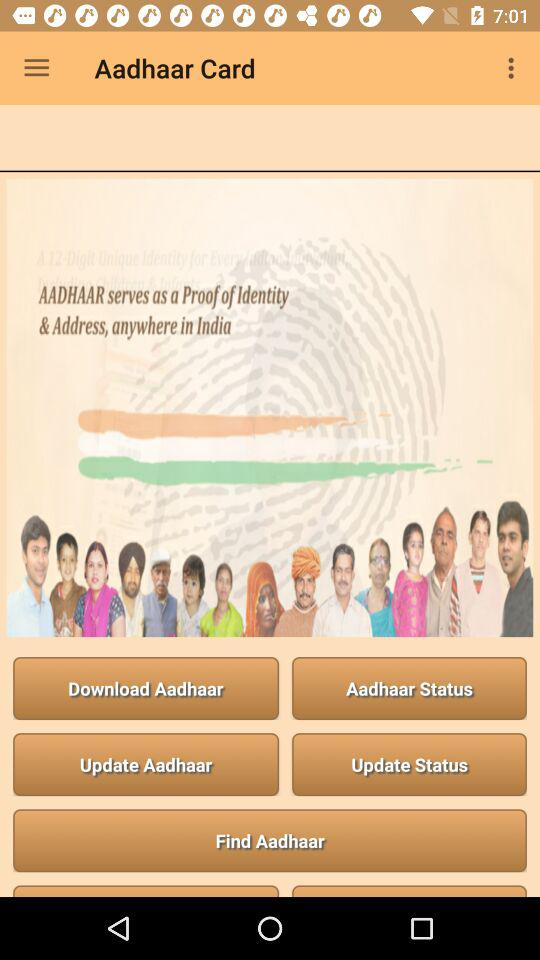What is the application name? The application name is "Aadhaar Card". 